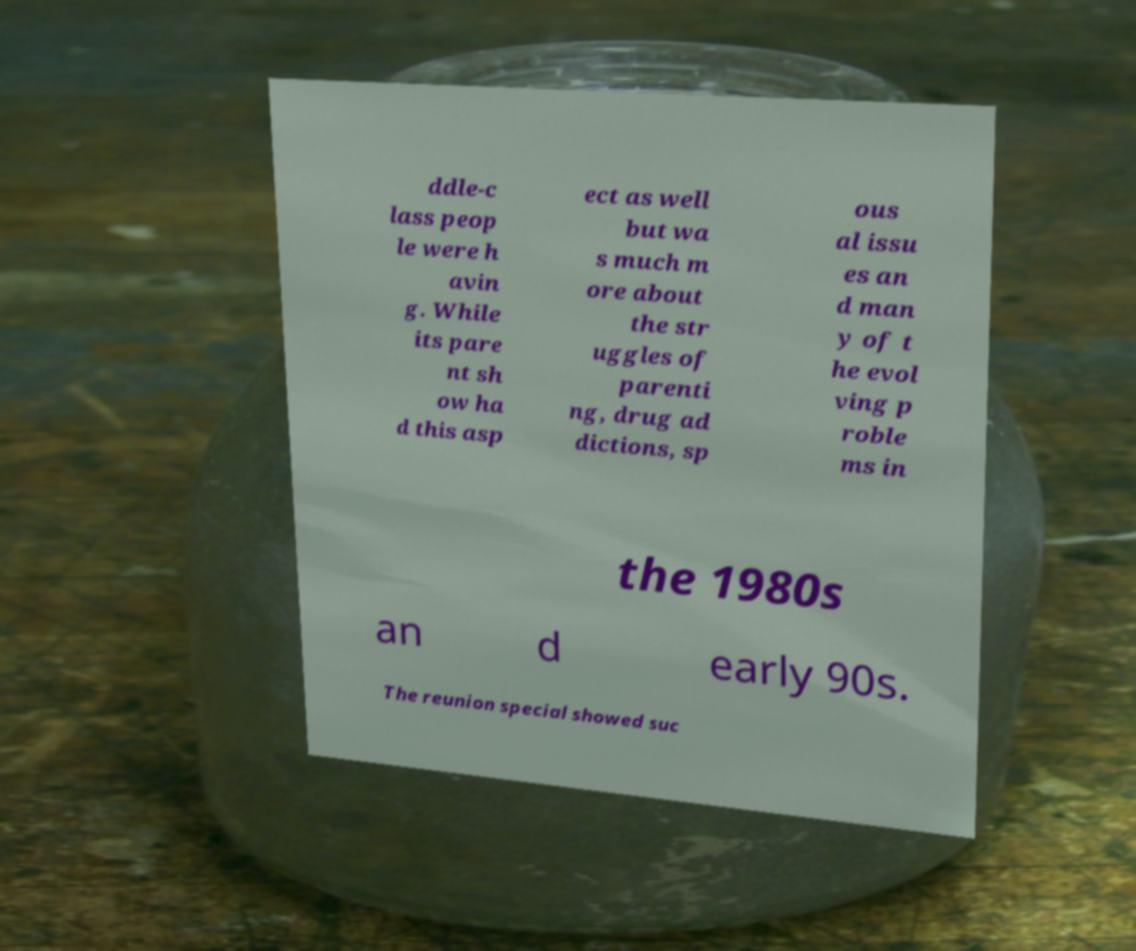Please identify and transcribe the text found in this image. ddle-c lass peop le were h avin g. While its pare nt sh ow ha d this asp ect as well but wa s much m ore about the str uggles of parenti ng, drug ad dictions, sp ous al issu es an d man y of t he evol ving p roble ms in the 1980s an d early 90s. The reunion special showed suc 